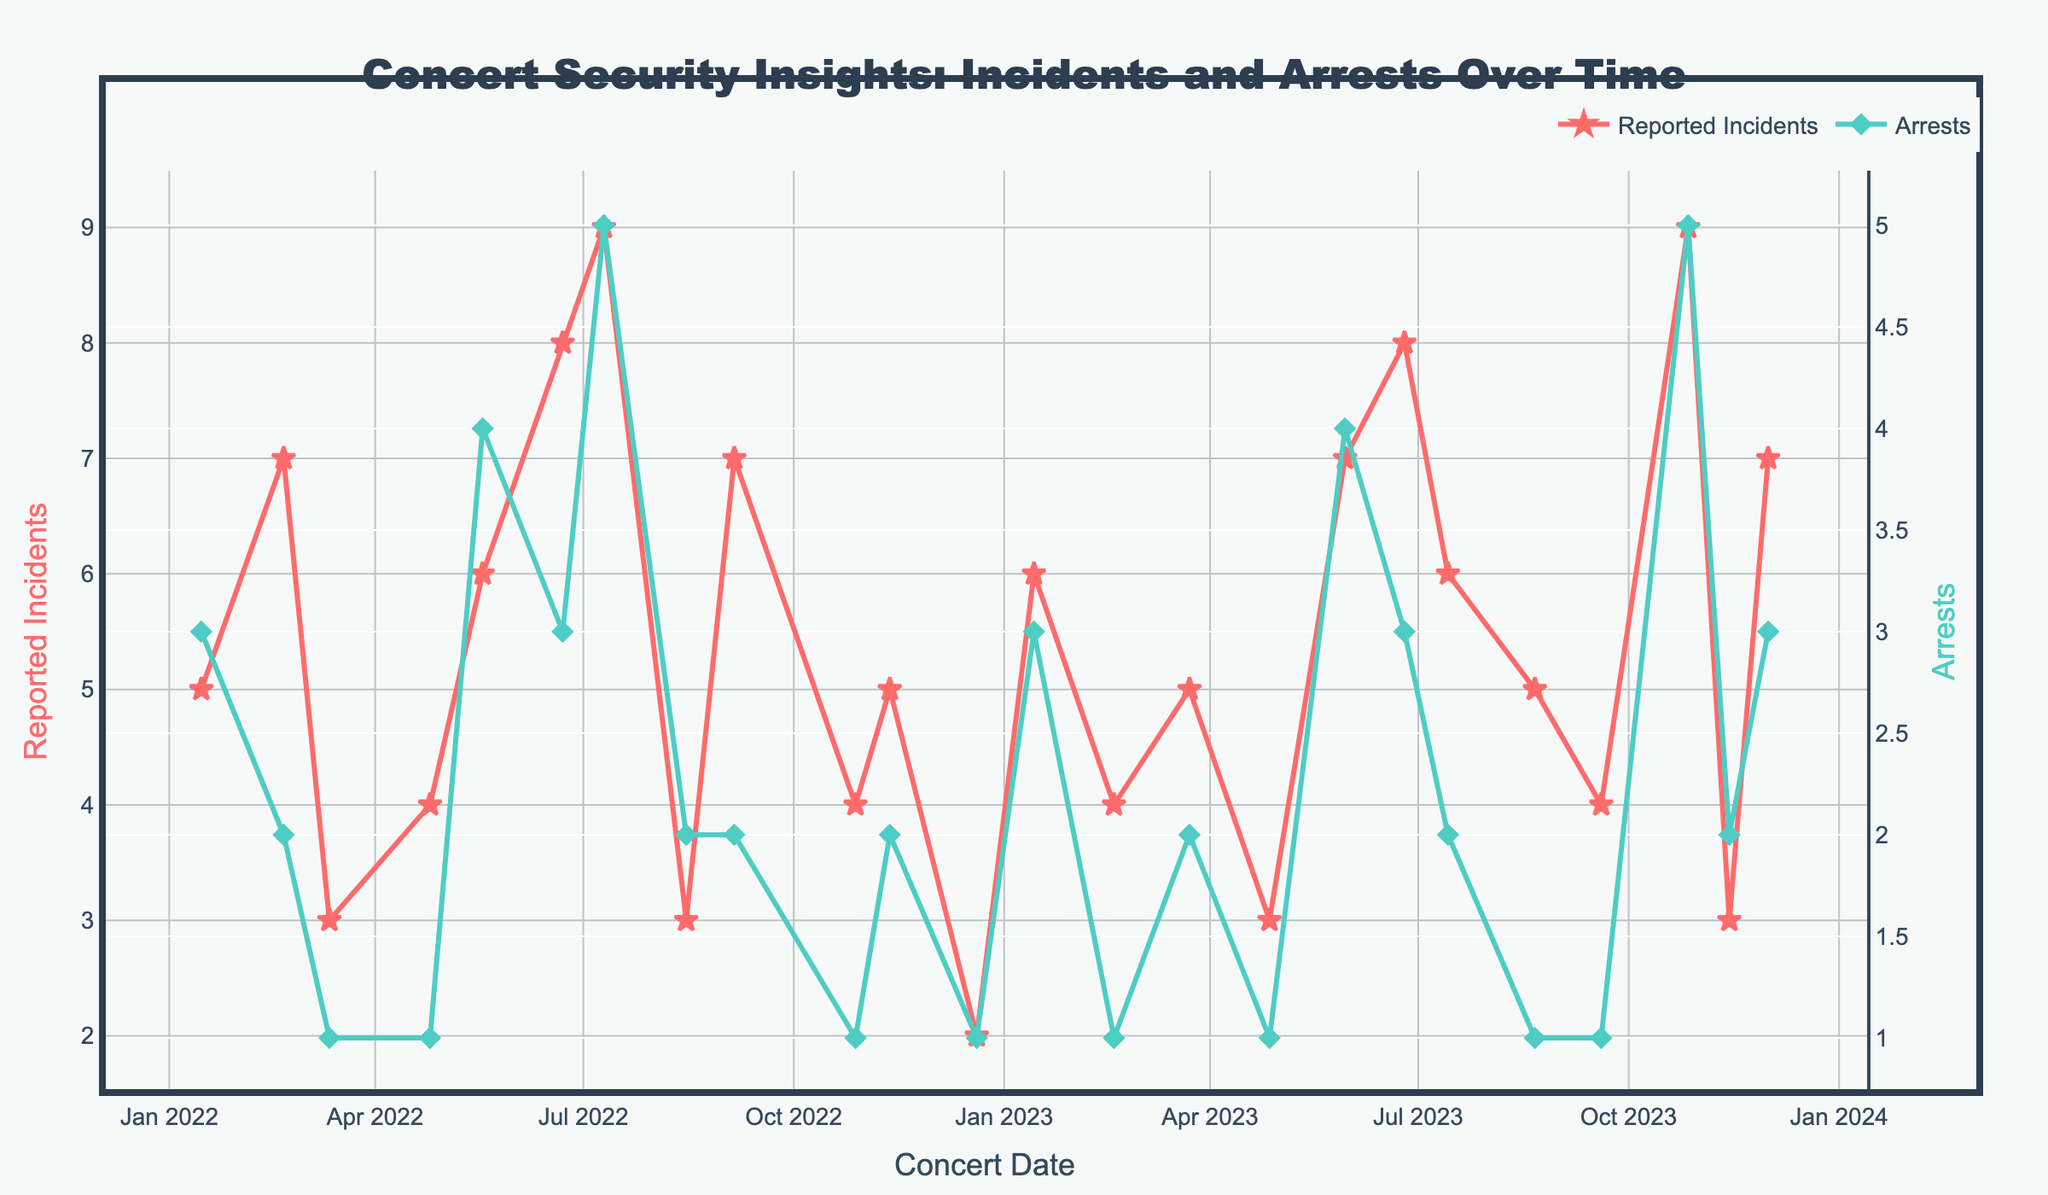what is the title of the figure? The title is prominently displayed at the top of the figure. It reads "Concert Security Insights: Incidents and Arrests Over Time" in a large font size.
Answer: Concert Security Insights: Incidents and Arrests Over Time How many concerts are shown in the plot? Each data point in the plot represents a concert, so counting the data points on the x-axis tells us the number of concerts. There are 24 data points, indicating 24 concerts.
Answer: 24 Which concert had the highest number of reported incidents? The highest point on the red 'Reported Incidents' line shows the maximum number. The peak of the red line is at 9 incidents, which corresponds to Maroon 5's concert on October 27, 2023.
Answer: Maroon 5 on October 27, 2023 After which concerts were the most arrests made? The peak of the green 'Arrests' line indicates the concerts with the most arrests. Maroon 5 on October 27, 2023, and Ariana Grande on July 10, 2022, both had the maximum number of arrests at 5.
Answer: Maroon 5 on October 27, 2023, and Ariana Grande on July 10, 2022 What is the range of reported incidents across all the concerts? To find the range, subtract the smallest number of reported incidents from the largest number. The smallest value on the red line is 2 (Adele's concert on December 20, 2022), and the largest is 9 (Maroon 5 on October 27, 2023). The range is 9 - 2.
Answer: 7 How did the number of reported incidents for concerts in Central Park trend over the two years? By observing the red line at the points where the x-axis labels indicate Central Park, the concerts had 5, 9, 6, and 6 reported incidents on January 15, 2022; July 10, 2022; January 14, 2023; and July 14, 2023, respectively. The trend shows fluctuations without a clear increasing or decreasing pattern.
Answer: Fluctuating What is the average number of reported incidents for concerts held in Downtown Arena? To find the average, add the reported incidents for all concerts held in Downtown Arena and divide by the number of such concerts. The incidents are 7, 3, 4, 5, which sum up to 19. There are 4 concerts, so the average is 19/4.
Answer: 4.75 Which concerts resulted in more arrests than reported incidents? By comparing the values of the red 'Reported Incidents' line and the green 'Arrests' line, we observe that Billie Eilish's concert on May 18, 2022, had 6 incidents but 4 arrests, which doesn't fit the criteria. No concert had more arrests than reported incidents.
Answer: None What is the total number of arrests made over all the concerts? Add all the values from the green 'Arrests' line. The sum is 3+2+1+1+4+3+5+2+2+1+2+1+3+1+2+1+4+3+2+1+5+2+3, which totals to 58.
Answer: 58 